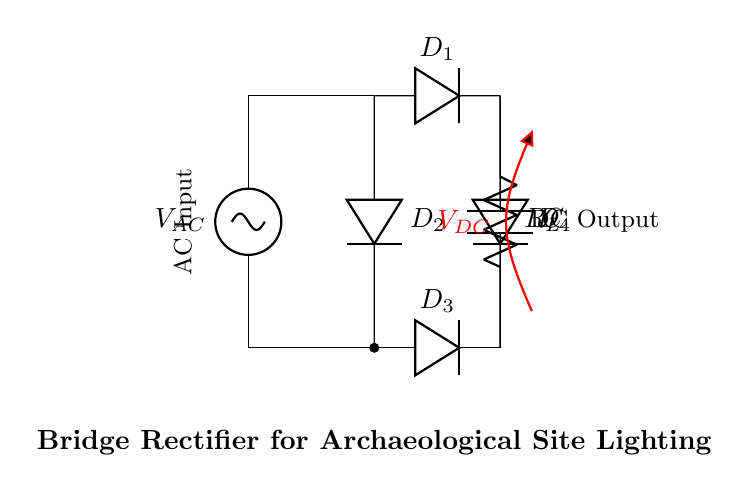What is the type of input voltage for this circuit? The circuit diagram indicates an AC source connected at the input. It is marked with a label $V_{AC}$.
Answer: AC What are the components used in the bridge rectifier? The bridge rectifier consists of four diodes labeled $D_1$, $D_2$, $D_3$, and $D_4$. Each of these diodes is represented in the diagram.
Answer: Four diodes What is the load connected to the output? The load is represented by a resistor labeled $R_L$, which is connected across the output terminals of the bridge rectifier.
Answer: Resistor What is the purpose of the capacitor in this circuit? The capacitor, labeled $C$, smooths the output voltage by filtering the ripples after rectification allowing for a more stable DC output voltage.
Answer: Smoothing What voltage is generated at the output of the bridge rectifier? The circuit diagram indicates a DC output voltage labeled $V_{DC}$, which is the voltage across the load resistor after rectification.
Answer: $V_{DC}$ How many diodes conduct when the input is in the positive half cycle? During the positive half cycle of the AC input, two diodes (specifically $D_1$ and $D_4$) conduct to allow current to flow through the load.
Answer: Two Why is a bridge rectifier used instead of a half-wave rectifier? A bridge rectifier enables both halves of the AC input wave to be utilized for output, enhancing efficiency and producing a higher average output voltage compared to a half-wave rectifier which only utilizes one half.
Answer: More efficient 